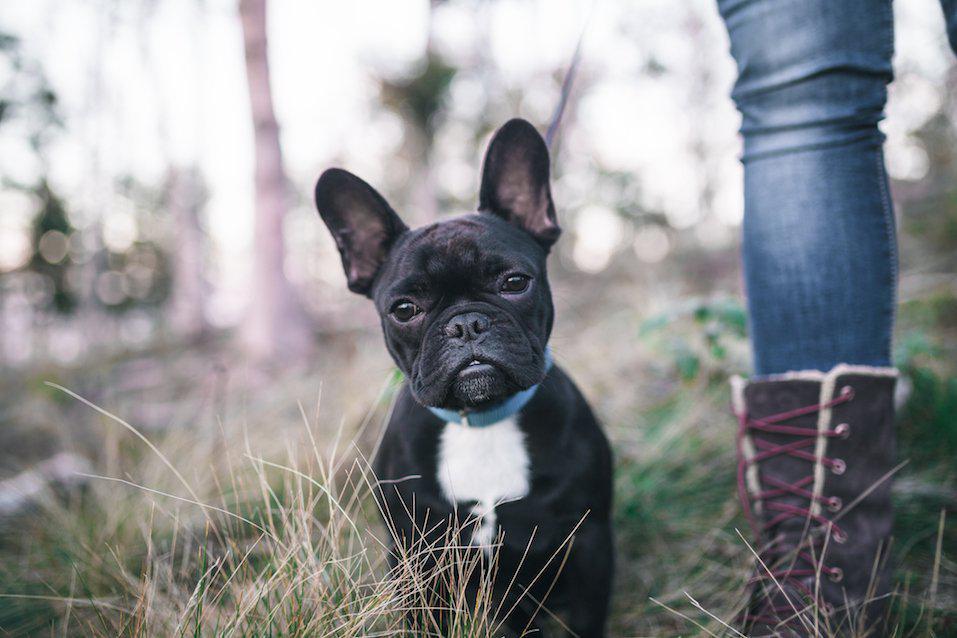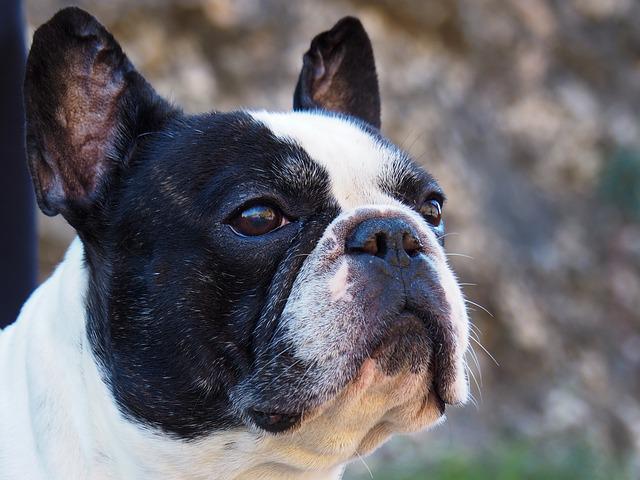The first image is the image on the left, the second image is the image on the right. Evaluate the accuracy of this statement regarding the images: "The french bulldog in the left image wears a collar and has a black container in front of its chest.". Is it true? Answer yes or no. No. The first image is the image on the left, the second image is the image on the right. Given the left and right images, does the statement "There are at least 3 dogs." hold true? Answer yes or no. No. 